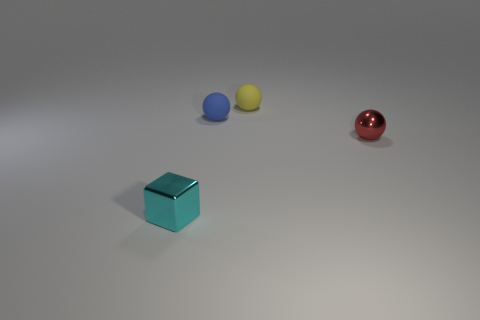Subtract all red cubes. Subtract all red cylinders. How many cubes are left? 1 Add 3 tiny things. How many objects exist? 7 Subtract all balls. How many objects are left? 1 Subtract all metal spheres. Subtract all tiny cyan things. How many objects are left? 2 Add 2 small blue matte things. How many small blue matte things are left? 3 Add 3 large purple blocks. How many large purple blocks exist? 3 Subtract 0 purple blocks. How many objects are left? 4 